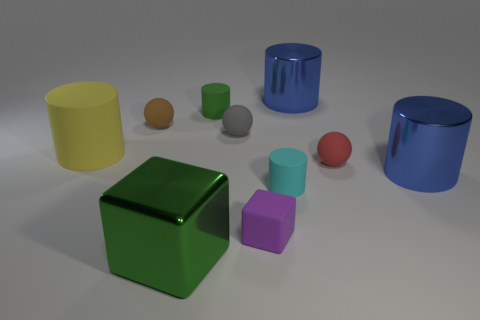What is the size of the cylinder that is right of the green rubber cylinder and behind the tiny brown rubber object?
Your answer should be very brief. Large. There is another tiny thing that is the same shape as the small green object; what is its color?
Provide a short and direct response. Cyan. Are there more yellow matte cylinders to the left of the cyan cylinder than tiny gray rubber things on the left side of the big cube?
Make the answer very short. Yes. How many other things are the same shape as the gray object?
Offer a very short reply. 2. Are there any yellow things that are behind the large cylinder that is behind the brown matte ball?
Your answer should be compact. No. How many red rubber balls are there?
Keep it short and to the point. 1. There is a large block; does it have the same color as the tiny cylinder that is to the left of the cyan matte object?
Make the answer very short. Yes. Is the number of yellow matte cylinders greater than the number of small green metallic balls?
Offer a terse response. Yes. Is there anything else of the same color as the tiny cube?
Provide a succinct answer. No. What number of other objects are there of the same size as the yellow rubber object?
Provide a succinct answer. 3. 